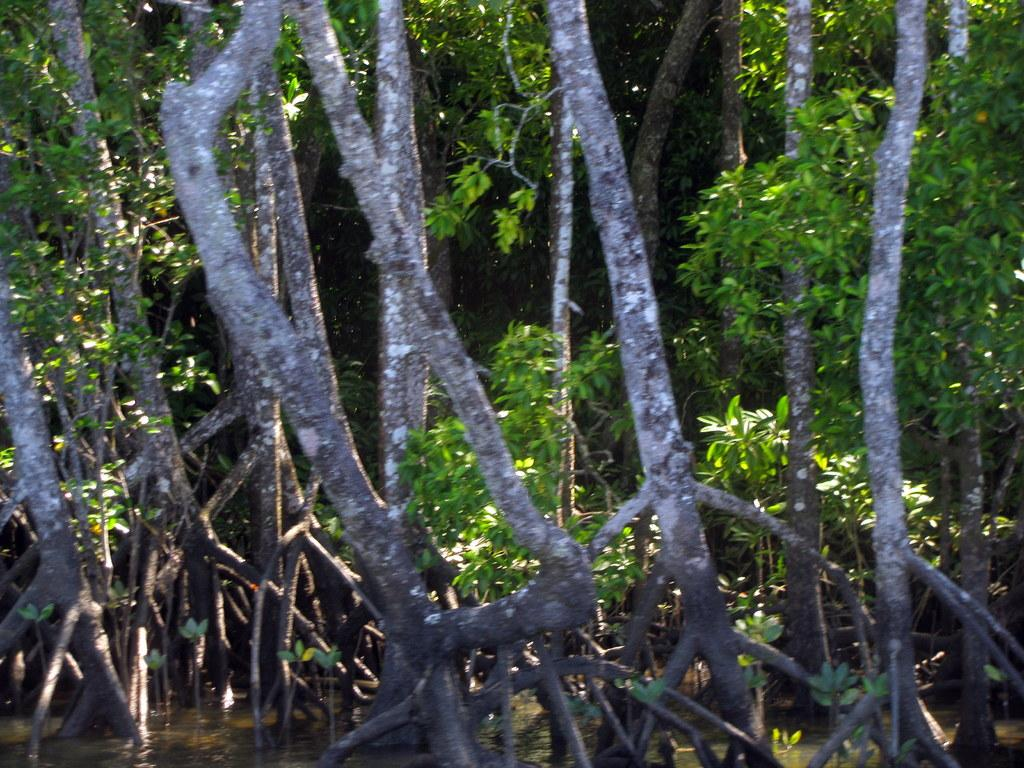What can be seen in the image? There is water visible in the image, and there are trees present as well. Can you describe the water in the image? The water is visible, but its depth or any specific features cannot be determined from the image alone. What type of vegetation is present in the image? Trees are the type of vegetation visible in the image. How many snails can be seen crawling on the trees in the image? There are no snails visible in the image; only water and trees are present. What color is the paint on the trees in the image? There is no paint on the trees in the image, as they are depicted in their natural state. 